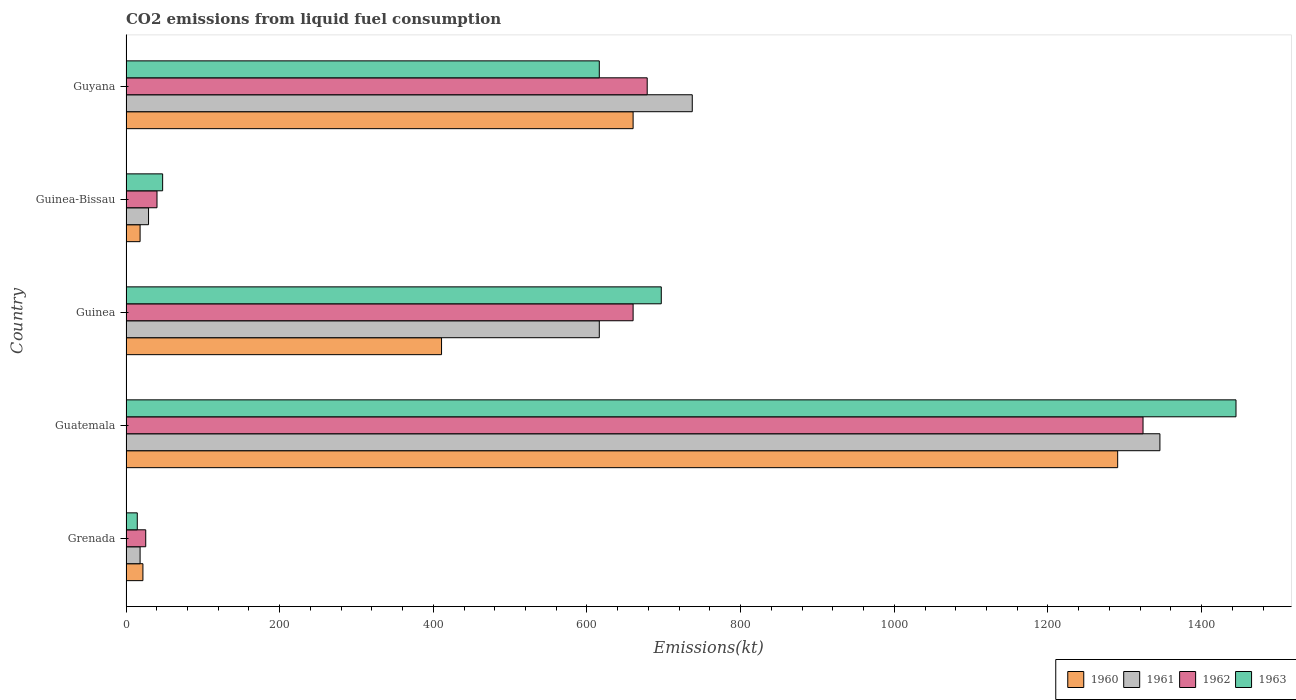Are the number of bars per tick equal to the number of legend labels?
Offer a very short reply. Yes. What is the label of the 2nd group of bars from the top?
Provide a short and direct response. Guinea-Bissau. What is the amount of CO2 emitted in 1962 in Guinea?
Your answer should be very brief. 660.06. Across all countries, what is the maximum amount of CO2 emitted in 1963?
Ensure brevity in your answer.  1444.8. Across all countries, what is the minimum amount of CO2 emitted in 1961?
Your answer should be very brief. 18.34. In which country was the amount of CO2 emitted in 1960 maximum?
Provide a short and direct response. Guatemala. In which country was the amount of CO2 emitted in 1960 minimum?
Provide a succinct answer. Guinea-Bissau. What is the total amount of CO2 emitted in 1963 in the graph?
Make the answer very short. 2819.92. What is the difference between the amount of CO2 emitted in 1963 in Grenada and that in Guyana?
Offer a very short reply. -601.39. What is the difference between the amount of CO2 emitted in 1962 in Guyana and the amount of CO2 emitted in 1961 in Guatemala?
Make the answer very short. -667.39. What is the average amount of CO2 emitted in 1961 per country?
Keep it short and to the point. 549.32. What is the difference between the amount of CO2 emitted in 1963 and amount of CO2 emitted in 1960 in Guinea?
Offer a terse response. 286.03. What is the ratio of the amount of CO2 emitted in 1963 in Guinea-Bissau to that in Guyana?
Give a very brief answer. 0.08. Is the amount of CO2 emitted in 1960 in Grenada less than that in Guatemala?
Ensure brevity in your answer.  Yes. What is the difference between the highest and the second highest amount of CO2 emitted in 1960?
Your answer should be compact. 630.72. What is the difference between the highest and the lowest amount of CO2 emitted in 1960?
Provide a short and direct response. 1272.45. Is it the case that in every country, the sum of the amount of CO2 emitted in 1963 and amount of CO2 emitted in 1960 is greater than the sum of amount of CO2 emitted in 1962 and amount of CO2 emitted in 1961?
Provide a succinct answer. No. Is it the case that in every country, the sum of the amount of CO2 emitted in 1962 and amount of CO2 emitted in 1961 is greater than the amount of CO2 emitted in 1963?
Make the answer very short. Yes. Are all the bars in the graph horizontal?
Give a very brief answer. Yes. What is the difference between two consecutive major ticks on the X-axis?
Offer a terse response. 200. Does the graph contain grids?
Make the answer very short. No. What is the title of the graph?
Provide a short and direct response. CO2 emissions from liquid fuel consumption. Does "1969" appear as one of the legend labels in the graph?
Offer a very short reply. No. What is the label or title of the X-axis?
Your answer should be compact. Emissions(kt). What is the Emissions(kt) of 1960 in Grenada?
Provide a succinct answer. 22. What is the Emissions(kt) in 1961 in Grenada?
Ensure brevity in your answer.  18.34. What is the Emissions(kt) of 1962 in Grenada?
Your answer should be very brief. 25.67. What is the Emissions(kt) of 1963 in Grenada?
Your answer should be compact. 14.67. What is the Emissions(kt) of 1960 in Guatemala?
Keep it short and to the point. 1290.78. What is the Emissions(kt) of 1961 in Guatemala?
Give a very brief answer. 1345.79. What is the Emissions(kt) of 1962 in Guatemala?
Offer a terse response. 1323.79. What is the Emissions(kt) of 1963 in Guatemala?
Ensure brevity in your answer.  1444.8. What is the Emissions(kt) in 1960 in Guinea?
Provide a succinct answer. 410.7. What is the Emissions(kt) in 1961 in Guinea?
Give a very brief answer. 616.06. What is the Emissions(kt) in 1962 in Guinea?
Give a very brief answer. 660.06. What is the Emissions(kt) of 1963 in Guinea?
Provide a succinct answer. 696.73. What is the Emissions(kt) in 1960 in Guinea-Bissau?
Offer a terse response. 18.34. What is the Emissions(kt) of 1961 in Guinea-Bissau?
Your answer should be very brief. 29.34. What is the Emissions(kt) in 1962 in Guinea-Bissau?
Give a very brief answer. 40.34. What is the Emissions(kt) in 1963 in Guinea-Bissau?
Your answer should be compact. 47.67. What is the Emissions(kt) in 1960 in Guyana?
Provide a short and direct response. 660.06. What is the Emissions(kt) in 1961 in Guyana?
Provide a succinct answer. 737.07. What is the Emissions(kt) in 1962 in Guyana?
Give a very brief answer. 678.39. What is the Emissions(kt) of 1963 in Guyana?
Provide a succinct answer. 616.06. Across all countries, what is the maximum Emissions(kt) in 1960?
Your answer should be very brief. 1290.78. Across all countries, what is the maximum Emissions(kt) in 1961?
Offer a very short reply. 1345.79. Across all countries, what is the maximum Emissions(kt) in 1962?
Your answer should be very brief. 1323.79. Across all countries, what is the maximum Emissions(kt) in 1963?
Your answer should be very brief. 1444.8. Across all countries, what is the minimum Emissions(kt) of 1960?
Offer a very short reply. 18.34. Across all countries, what is the minimum Emissions(kt) of 1961?
Make the answer very short. 18.34. Across all countries, what is the minimum Emissions(kt) in 1962?
Make the answer very short. 25.67. Across all countries, what is the minimum Emissions(kt) in 1963?
Your response must be concise. 14.67. What is the total Emissions(kt) of 1960 in the graph?
Provide a short and direct response. 2401.89. What is the total Emissions(kt) in 1961 in the graph?
Provide a short and direct response. 2746.58. What is the total Emissions(kt) of 1962 in the graph?
Your response must be concise. 2728.25. What is the total Emissions(kt) in 1963 in the graph?
Your answer should be compact. 2819.92. What is the difference between the Emissions(kt) of 1960 in Grenada and that in Guatemala?
Provide a succinct answer. -1268.78. What is the difference between the Emissions(kt) in 1961 in Grenada and that in Guatemala?
Offer a terse response. -1327.45. What is the difference between the Emissions(kt) of 1962 in Grenada and that in Guatemala?
Offer a very short reply. -1298.12. What is the difference between the Emissions(kt) in 1963 in Grenada and that in Guatemala?
Give a very brief answer. -1430.13. What is the difference between the Emissions(kt) in 1960 in Grenada and that in Guinea?
Your answer should be compact. -388.7. What is the difference between the Emissions(kt) of 1961 in Grenada and that in Guinea?
Provide a short and direct response. -597.72. What is the difference between the Emissions(kt) in 1962 in Grenada and that in Guinea?
Your answer should be very brief. -634.39. What is the difference between the Emissions(kt) of 1963 in Grenada and that in Guinea?
Offer a very short reply. -682.06. What is the difference between the Emissions(kt) in 1960 in Grenada and that in Guinea-Bissau?
Your answer should be compact. 3.67. What is the difference between the Emissions(kt) of 1961 in Grenada and that in Guinea-Bissau?
Make the answer very short. -11. What is the difference between the Emissions(kt) of 1962 in Grenada and that in Guinea-Bissau?
Make the answer very short. -14.67. What is the difference between the Emissions(kt) in 1963 in Grenada and that in Guinea-Bissau?
Your response must be concise. -33. What is the difference between the Emissions(kt) of 1960 in Grenada and that in Guyana?
Ensure brevity in your answer.  -638.06. What is the difference between the Emissions(kt) of 1961 in Grenada and that in Guyana?
Offer a very short reply. -718.73. What is the difference between the Emissions(kt) in 1962 in Grenada and that in Guyana?
Your answer should be compact. -652.73. What is the difference between the Emissions(kt) in 1963 in Grenada and that in Guyana?
Your response must be concise. -601.39. What is the difference between the Emissions(kt) in 1960 in Guatemala and that in Guinea?
Provide a short and direct response. 880.08. What is the difference between the Emissions(kt) of 1961 in Guatemala and that in Guinea?
Offer a terse response. 729.73. What is the difference between the Emissions(kt) of 1962 in Guatemala and that in Guinea?
Offer a terse response. 663.73. What is the difference between the Emissions(kt) in 1963 in Guatemala and that in Guinea?
Offer a terse response. 748.07. What is the difference between the Emissions(kt) in 1960 in Guatemala and that in Guinea-Bissau?
Give a very brief answer. 1272.45. What is the difference between the Emissions(kt) of 1961 in Guatemala and that in Guinea-Bissau?
Give a very brief answer. 1316.45. What is the difference between the Emissions(kt) in 1962 in Guatemala and that in Guinea-Bissau?
Keep it short and to the point. 1283.45. What is the difference between the Emissions(kt) in 1963 in Guatemala and that in Guinea-Bissau?
Provide a succinct answer. 1397.13. What is the difference between the Emissions(kt) in 1960 in Guatemala and that in Guyana?
Your answer should be compact. 630.72. What is the difference between the Emissions(kt) in 1961 in Guatemala and that in Guyana?
Provide a short and direct response. 608.72. What is the difference between the Emissions(kt) in 1962 in Guatemala and that in Guyana?
Your answer should be very brief. 645.39. What is the difference between the Emissions(kt) in 1963 in Guatemala and that in Guyana?
Provide a short and direct response. 828.74. What is the difference between the Emissions(kt) in 1960 in Guinea and that in Guinea-Bissau?
Offer a very short reply. 392.37. What is the difference between the Emissions(kt) in 1961 in Guinea and that in Guinea-Bissau?
Keep it short and to the point. 586.72. What is the difference between the Emissions(kt) of 1962 in Guinea and that in Guinea-Bissau?
Your response must be concise. 619.72. What is the difference between the Emissions(kt) in 1963 in Guinea and that in Guinea-Bissau?
Your response must be concise. 649.06. What is the difference between the Emissions(kt) of 1960 in Guinea and that in Guyana?
Keep it short and to the point. -249.36. What is the difference between the Emissions(kt) of 1961 in Guinea and that in Guyana?
Offer a very short reply. -121.01. What is the difference between the Emissions(kt) in 1962 in Guinea and that in Guyana?
Provide a succinct answer. -18.34. What is the difference between the Emissions(kt) of 1963 in Guinea and that in Guyana?
Offer a very short reply. 80.67. What is the difference between the Emissions(kt) of 1960 in Guinea-Bissau and that in Guyana?
Ensure brevity in your answer.  -641.73. What is the difference between the Emissions(kt) of 1961 in Guinea-Bissau and that in Guyana?
Ensure brevity in your answer.  -707.73. What is the difference between the Emissions(kt) in 1962 in Guinea-Bissau and that in Guyana?
Your answer should be compact. -638.06. What is the difference between the Emissions(kt) in 1963 in Guinea-Bissau and that in Guyana?
Provide a succinct answer. -568.38. What is the difference between the Emissions(kt) in 1960 in Grenada and the Emissions(kt) in 1961 in Guatemala?
Offer a terse response. -1323.79. What is the difference between the Emissions(kt) of 1960 in Grenada and the Emissions(kt) of 1962 in Guatemala?
Make the answer very short. -1301.79. What is the difference between the Emissions(kt) in 1960 in Grenada and the Emissions(kt) in 1963 in Guatemala?
Ensure brevity in your answer.  -1422.8. What is the difference between the Emissions(kt) in 1961 in Grenada and the Emissions(kt) in 1962 in Guatemala?
Give a very brief answer. -1305.45. What is the difference between the Emissions(kt) of 1961 in Grenada and the Emissions(kt) of 1963 in Guatemala?
Your answer should be very brief. -1426.46. What is the difference between the Emissions(kt) of 1962 in Grenada and the Emissions(kt) of 1963 in Guatemala?
Your answer should be compact. -1419.13. What is the difference between the Emissions(kt) of 1960 in Grenada and the Emissions(kt) of 1961 in Guinea?
Your answer should be compact. -594.05. What is the difference between the Emissions(kt) of 1960 in Grenada and the Emissions(kt) of 1962 in Guinea?
Offer a very short reply. -638.06. What is the difference between the Emissions(kt) of 1960 in Grenada and the Emissions(kt) of 1963 in Guinea?
Provide a succinct answer. -674.73. What is the difference between the Emissions(kt) in 1961 in Grenada and the Emissions(kt) in 1962 in Guinea?
Your answer should be compact. -641.73. What is the difference between the Emissions(kt) in 1961 in Grenada and the Emissions(kt) in 1963 in Guinea?
Ensure brevity in your answer.  -678.39. What is the difference between the Emissions(kt) of 1962 in Grenada and the Emissions(kt) of 1963 in Guinea?
Provide a succinct answer. -671.06. What is the difference between the Emissions(kt) of 1960 in Grenada and the Emissions(kt) of 1961 in Guinea-Bissau?
Provide a succinct answer. -7.33. What is the difference between the Emissions(kt) in 1960 in Grenada and the Emissions(kt) in 1962 in Guinea-Bissau?
Make the answer very short. -18.34. What is the difference between the Emissions(kt) in 1960 in Grenada and the Emissions(kt) in 1963 in Guinea-Bissau?
Your answer should be compact. -25.67. What is the difference between the Emissions(kt) in 1961 in Grenada and the Emissions(kt) in 1962 in Guinea-Bissau?
Your answer should be very brief. -22. What is the difference between the Emissions(kt) in 1961 in Grenada and the Emissions(kt) in 1963 in Guinea-Bissau?
Give a very brief answer. -29.34. What is the difference between the Emissions(kt) of 1962 in Grenada and the Emissions(kt) of 1963 in Guinea-Bissau?
Ensure brevity in your answer.  -22. What is the difference between the Emissions(kt) of 1960 in Grenada and the Emissions(kt) of 1961 in Guyana?
Your answer should be compact. -715.07. What is the difference between the Emissions(kt) in 1960 in Grenada and the Emissions(kt) in 1962 in Guyana?
Your response must be concise. -656.39. What is the difference between the Emissions(kt) of 1960 in Grenada and the Emissions(kt) of 1963 in Guyana?
Make the answer very short. -594.05. What is the difference between the Emissions(kt) of 1961 in Grenada and the Emissions(kt) of 1962 in Guyana?
Your answer should be very brief. -660.06. What is the difference between the Emissions(kt) of 1961 in Grenada and the Emissions(kt) of 1963 in Guyana?
Provide a short and direct response. -597.72. What is the difference between the Emissions(kt) in 1962 in Grenada and the Emissions(kt) in 1963 in Guyana?
Offer a very short reply. -590.39. What is the difference between the Emissions(kt) of 1960 in Guatemala and the Emissions(kt) of 1961 in Guinea?
Provide a short and direct response. 674.73. What is the difference between the Emissions(kt) of 1960 in Guatemala and the Emissions(kt) of 1962 in Guinea?
Offer a terse response. 630.72. What is the difference between the Emissions(kt) in 1960 in Guatemala and the Emissions(kt) in 1963 in Guinea?
Your answer should be compact. 594.05. What is the difference between the Emissions(kt) of 1961 in Guatemala and the Emissions(kt) of 1962 in Guinea?
Offer a very short reply. 685.73. What is the difference between the Emissions(kt) in 1961 in Guatemala and the Emissions(kt) in 1963 in Guinea?
Give a very brief answer. 649.06. What is the difference between the Emissions(kt) of 1962 in Guatemala and the Emissions(kt) of 1963 in Guinea?
Your answer should be very brief. 627.06. What is the difference between the Emissions(kt) in 1960 in Guatemala and the Emissions(kt) in 1961 in Guinea-Bissau?
Make the answer very short. 1261.45. What is the difference between the Emissions(kt) in 1960 in Guatemala and the Emissions(kt) in 1962 in Guinea-Bissau?
Offer a very short reply. 1250.45. What is the difference between the Emissions(kt) in 1960 in Guatemala and the Emissions(kt) in 1963 in Guinea-Bissau?
Your response must be concise. 1243.11. What is the difference between the Emissions(kt) of 1961 in Guatemala and the Emissions(kt) of 1962 in Guinea-Bissau?
Provide a succinct answer. 1305.45. What is the difference between the Emissions(kt) in 1961 in Guatemala and the Emissions(kt) in 1963 in Guinea-Bissau?
Keep it short and to the point. 1298.12. What is the difference between the Emissions(kt) in 1962 in Guatemala and the Emissions(kt) in 1963 in Guinea-Bissau?
Offer a terse response. 1276.12. What is the difference between the Emissions(kt) in 1960 in Guatemala and the Emissions(kt) in 1961 in Guyana?
Provide a succinct answer. 553.72. What is the difference between the Emissions(kt) in 1960 in Guatemala and the Emissions(kt) in 1962 in Guyana?
Keep it short and to the point. 612.39. What is the difference between the Emissions(kt) of 1960 in Guatemala and the Emissions(kt) of 1963 in Guyana?
Provide a succinct answer. 674.73. What is the difference between the Emissions(kt) in 1961 in Guatemala and the Emissions(kt) in 1962 in Guyana?
Your answer should be very brief. 667.39. What is the difference between the Emissions(kt) in 1961 in Guatemala and the Emissions(kt) in 1963 in Guyana?
Provide a succinct answer. 729.73. What is the difference between the Emissions(kt) of 1962 in Guatemala and the Emissions(kt) of 1963 in Guyana?
Offer a terse response. 707.73. What is the difference between the Emissions(kt) of 1960 in Guinea and the Emissions(kt) of 1961 in Guinea-Bissau?
Ensure brevity in your answer.  381.37. What is the difference between the Emissions(kt) in 1960 in Guinea and the Emissions(kt) in 1962 in Guinea-Bissau?
Keep it short and to the point. 370.37. What is the difference between the Emissions(kt) of 1960 in Guinea and the Emissions(kt) of 1963 in Guinea-Bissau?
Ensure brevity in your answer.  363.03. What is the difference between the Emissions(kt) of 1961 in Guinea and the Emissions(kt) of 1962 in Guinea-Bissau?
Make the answer very short. 575.72. What is the difference between the Emissions(kt) in 1961 in Guinea and the Emissions(kt) in 1963 in Guinea-Bissau?
Provide a succinct answer. 568.38. What is the difference between the Emissions(kt) of 1962 in Guinea and the Emissions(kt) of 1963 in Guinea-Bissau?
Offer a very short reply. 612.39. What is the difference between the Emissions(kt) of 1960 in Guinea and the Emissions(kt) of 1961 in Guyana?
Provide a succinct answer. -326.36. What is the difference between the Emissions(kt) in 1960 in Guinea and the Emissions(kt) in 1962 in Guyana?
Keep it short and to the point. -267.69. What is the difference between the Emissions(kt) of 1960 in Guinea and the Emissions(kt) of 1963 in Guyana?
Your answer should be compact. -205.35. What is the difference between the Emissions(kt) in 1961 in Guinea and the Emissions(kt) in 1962 in Guyana?
Keep it short and to the point. -62.34. What is the difference between the Emissions(kt) of 1961 in Guinea and the Emissions(kt) of 1963 in Guyana?
Your answer should be compact. 0. What is the difference between the Emissions(kt) of 1962 in Guinea and the Emissions(kt) of 1963 in Guyana?
Offer a terse response. 44. What is the difference between the Emissions(kt) of 1960 in Guinea-Bissau and the Emissions(kt) of 1961 in Guyana?
Make the answer very short. -718.73. What is the difference between the Emissions(kt) in 1960 in Guinea-Bissau and the Emissions(kt) in 1962 in Guyana?
Provide a short and direct response. -660.06. What is the difference between the Emissions(kt) in 1960 in Guinea-Bissau and the Emissions(kt) in 1963 in Guyana?
Ensure brevity in your answer.  -597.72. What is the difference between the Emissions(kt) in 1961 in Guinea-Bissau and the Emissions(kt) in 1962 in Guyana?
Keep it short and to the point. -649.06. What is the difference between the Emissions(kt) of 1961 in Guinea-Bissau and the Emissions(kt) of 1963 in Guyana?
Give a very brief answer. -586.72. What is the difference between the Emissions(kt) of 1962 in Guinea-Bissau and the Emissions(kt) of 1963 in Guyana?
Offer a terse response. -575.72. What is the average Emissions(kt) in 1960 per country?
Your answer should be very brief. 480.38. What is the average Emissions(kt) in 1961 per country?
Make the answer very short. 549.32. What is the average Emissions(kt) in 1962 per country?
Your answer should be compact. 545.65. What is the average Emissions(kt) in 1963 per country?
Offer a terse response. 563.98. What is the difference between the Emissions(kt) in 1960 and Emissions(kt) in 1961 in Grenada?
Make the answer very short. 3.67. What is the difference between the Emissions(kt) of 1960 and Emissions(kt) of 1962 in Grenada?
Provide a short and direct response. -3.67. What is the difference between the Emissions(kt) in 1960 and Emissions(kt) in 1963 in Grenada?
Your answer should be very brief. 7.33. What is the difference between the Emissions(kt) in 1961 and Emissions(kt) in 1962 in Grenada?
Provide a short and direct response. -7.33. What is the difference between the Emissions(kt) of 1961 and Emissions(kt) of 1963 in Grenada?
Keep it short and to the point. 3.67. What is the difference between the Emissions(kt) in 1962 and Emissions(kt) in 1963 in Grenada?
Offer a terse response. 11. What is the difference between the Emissions(kt) of 1960 and Emissions(kt) of 1961 in Guatemala?
Give a very brief answer. -55.01. What is the difference between the Emissions(kt) of 1960 and Emissions(kt) of 1962 in Guatemala?
Provide a succinct answer. -33. What is the difference between the Emissions(kt) of 1960 and Emissions(kt) of 1963 in Guatemala?
Your answer should be very brief. -154.01. What is the difference between the Emissions(kt) in 1961 and Emissions(kt) in 1962 in Guatemala?
Your answer should be compact. 22. What is the difference between the Emissions(kt) of 1961 and Emissions(kt) of 1963 in Guatemala?
Make the answer very short. -99.01. What is the difference between the Emissions(kt) of 1962 and Emissions(kt) of 1963 in Guatemala?
Keep it short and to the point. -121.01. What is the difference between the Emissions(kt) of 1960 and Emissions(kt) of 1961 in Guinea?
Your answer should be very brief. -205.35. What is the difference between the Emissions(kt) of 1960 and Emissions(kt) of 1962 in Guinea?
Provide a succinct answer. -249.36. What is the difference between the Emissions(kt) of 1960 and Emissions(kt) of 1963 in Guinea?
Ensure brevity in your answer.  -286.03. What is the difference between the Emissions(kt) of 1961 and Emissions(kt) of 1962 in Guinea?
Keep it short and to the point. -44. What is the difference between the Emissions(kt) in 1961 and Emissions(kt) in 1963 in Guinea?
Your answer should be very brief. -80.67. What is the difference between the Emissions(kt) in 1962 and Emissions(kt) in 1963 in Guinea?
Provide a short and direct response. -36.67. What is the difference between the Emissions(kt) in 1960 and Emissions(kt) in 1961 in Guinea-Bissau?
Your answer should be compact. -11. What is the difference between the Emissions(kt) in 1960 and Emissions(kt) in 1962 in Guinea-Bissau?
Your response must be concise. -22. What is the difference between the Emissions(kt) in 1960 and Emissions(kt) in 1963 in Guinea-Bissau?
Offer a very short reply. -29.34. What is the difference between the Emissions(kt) in 1961 and Emissions(kt) in 1962 in Guinea-Bissau?
Make the answer very short. -11. What is the difference between the Emissions(kt) in 1961 and Emissions(kt) in 1963 in Guinea-Bissau?
Your response must be concise. -18.34. What is the difference between the Emissions(kt) in 1962 and Emissions(kt) in 1963 in Guinea-Bissau?
Make the answer very short. -7.33. What is the difference between the Emissions(kt) in 1960 and Emissions(kt) in 1961 in Guyana?
Provide a short and direct response. -77.01. What is the difference between the Emissions(kt) of 1960 and Emissions(kt) of 1962 in Guyana?
Offer a terse response. -18.34. What is the difference between the Emissions(kt) of 1960 and Emissions(kt) of 1963 in Guyana?
Provide a short and direct response. 44. What is the difference between the Emissions(kt) in 1961 and Emissions(kt) in 1962 in Guyana?
Make the answer very short. 58.67. What is the difference between the Emissions(kt) in 1961 and Emissions(kt) in 1963 in Guyana?
Your answer should be compact. 121.01. What is the difference between the Emissions(kt) in 1962 and Emissions(kt) in 1963 in Guyana?
Offer a very short reply. 62.34. What is the ratio of the Emissions(kt) of 1960 in Grenada to that in Guatemala?
Your response must be concise. 0.02. What is the ratio of the Emissions(kt) of 1961 in Grenada to that in Guatemala?
Offer a very short reply. 0.01. What is the ratio of the Emissions(kt) of 1962 in Grenada to that in Guatemala?
Offer a terse response. 0.02. What is the ratio of the Emissions(kt) in 1963 in Grenada to that in Guatemala?
Provide a succinct answer. 0.01. What is the ratio of the Emissions(kt) in 1960 in Grenada to that in Guinea?
Your answer should be very brief. 0.05. What is the ratio of the Emissions(kt) of 1961 in Grenada to that in Guinea?
Your response must be concise. 0.03. What is the ratio of the Emissions(kt) of 1962 in Grenada to that in Guinea?
Provide a succinct answer. 0.04. What is the ratio of the Emissions(kt) in 1963 in Grenada to that in Guinea?
Your answer should be very brief. 0.02. What is the ratio of the Emissions(kt) of 1960 in Grenada to that in Guinea-Bissau?
Your response must be concise. 1.2. What is the ratio of the Emissions(kt) in 1962 in Grenada to that in Guinea-Bissau?
Your response must be concise. 0.64. What is the ratio of the Emissions(kt) of 1963 in Grenada to that in Guinea-Bissau?
Provide a succinct answer. 0.31. What is the ratio of the Emissions(kt) in 1961 in Grenada to that in Guyana?
Give a very brief answer. 0.02. What is the ratio of the Emissions(kt) of 1962 in Grenada to that in Guyana?
Make the answer very short. 0.04. What is the ratio of the Emissions(kt) of 1963 in Grenada to that in Guyana?
Ensure brevity in your answer.  0.02. What is the ratio of the Emissions(kt) of 1960 in Guatemala to that in Guinea?
Offer a very short reply. 3.14. What is the ratio of the Emissions(kt) in 1961 in Guatemala to that in Guinea?
Keep it short and to the point. 2.18. What is the ratio of the Emissions(kt) of 1962 in Guatemala to that in Guinea?
Make the answer very short. 2.01. What is the ratio of the Emissions(kt) in 1963 in Guatemala to that in Guinea?
Make the answer very short. 2.07. What is the ratio of the Emissions(kt) of 1960 in Guatemala to that in Guinea-Bissau?
Offer a very short reply. 70.4. What is the ratio of the Emissions(kt) of 1961 in Guatemala to that in Guinea-Bissau?
Give a very brief answer. 45.88. What is the ratio of the Emissions(kt) of 1962 in Guatemala to that in Guinea-Bissau?
Make the answer very short. 32.82. What is the ratio of the Emissions(kt) of 1963 in Guatemala to that in Guinea-Bissau?
Your answer should be very brief. 30.31. What is the ratio of the Emissions(kt) of 1960 in Guatemala to that in Guyana?
Your response must be concise. 1.96. What is the ratio of the Emissions(kt) of 1961 in Guatemala to that in Guyana?
Provide a succinct answer. 1.83. What is the ratio of the Emissions(kt) of 1962 in Guatemala to that in Guyana?
Your answer should be very brief. 1.95. What is the ratio of the Emissions(kt) in 1963 in Guatemala to that in Guyana?
Make the answer very short. 2.35. What is the ratio of the Emissions(kt) of 1960 in Guinea to that in Guinea-Bissau?
Offer a terse response. 22.4. What is the ratio of the Emissions(kt) of 1962 in Guinea to that in Guinea-Bissau?
Provide a succinct answer. 16.36. What is the ratio of the Emissions(kt) of 1963 in Guinea to that in Guinea-Bissau?
Provide a succinct answer. 14.62. What is the ratio of the Emissions(kt) in 1960 in Guinea to that in Guyana?
Provide a succinct answer. 0.62. What is the ratio of the Emissions(kt) in 1961 in Guinea to that in Guyana?
Your answer should be compact. 0.84. What is the ratio of the Emissions(kt) of 1962 in Guinea to that in Guyana?
Your response must be concise. 0.97. What is the ratio of the Emissions(kt) of 1963 in Guinea to that in Guyana?
Your answer should be compact. 1.13. What is the ratio of the Emissions(kt) in 1960 in Guinea-Bissau to that in Guyana?
Offer a very short reply. 0.03. What is the ratio of the Emissions(kt) of 1961 in Guinea-Bissau to that in Guyana?
Give a very brief answer. 0.04. What is the ratio of the Emissions(kt) in 1962 in Guinea-Bissau to that in Guyana?
Your answer should be compact. 0.06. What is the ratio of the Emissions(kt) in 1963 in Guinea-Bissau to that in Guyana?
Your answer should be compact. 0.08. What is the difference between the highest and the second highest Emissions(kt) in 1960?
Give a very brief answer. 630.72. What is the difference between the highest and the second highest Emissions(kt) of 1961?
Your response must be concise. 608.72. What is the difference between the highest and the second highest Emissions(kt) in 1962?
Keep it short and to the point. 645.39. What is the difference between the highest and the second highest Emissions(kt) of 1963?
Offer a very short reply. 748.07. What is the difference between the highest and the lowest Emissions(kt) in 1960?
Make the answer very short. 1272.45. What is the difference between the highest and the lowest Emissions(kt) in 1961?
Provide a short and direct response. 1327.45. What is the difference between the highest and the lowest Emissions(kt) in 1962?
Keep it short and to the point. 1298.12. What is the difference between the highest and the lowest Emissions(kt) of 1963?
Offer a very short reply. 1430.13. 